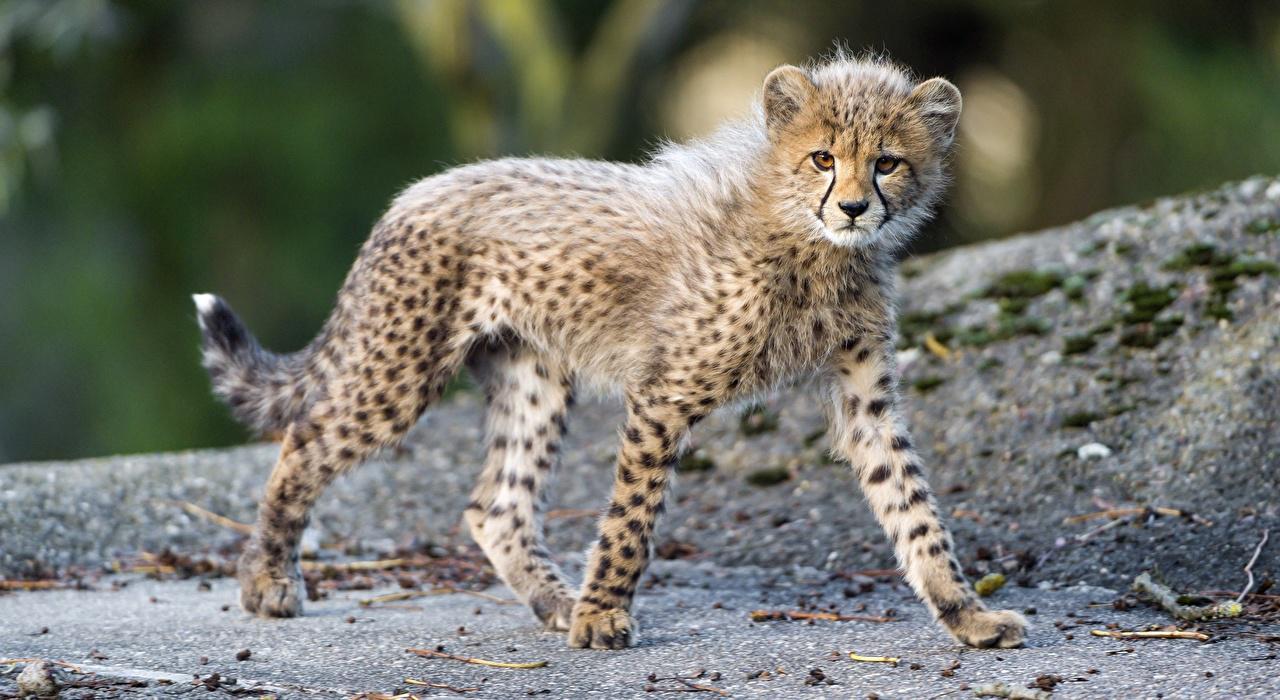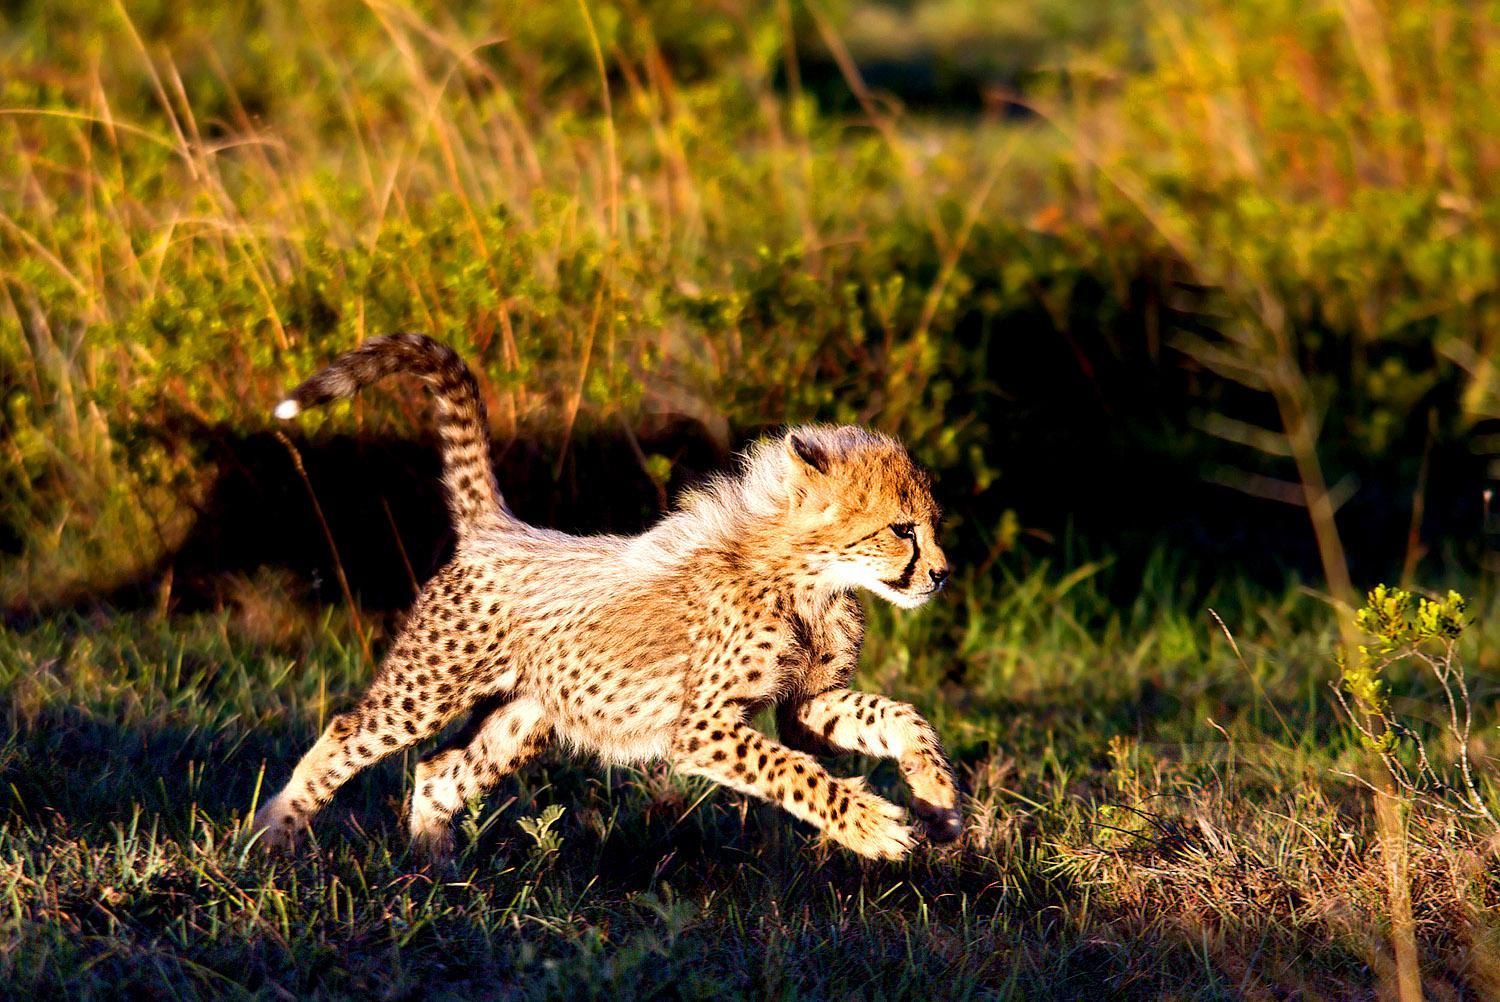The first image is the image on the left, the second image is the image on the right. For the images shown, is this caption "the right pic has two cheetahs" true? Answer yes or no. No. The first image is the image on the left, the second image is the image on the right. Given the left and right images, does the statement "A cheetah is yawning." hold true? Answer yes or no. No. 